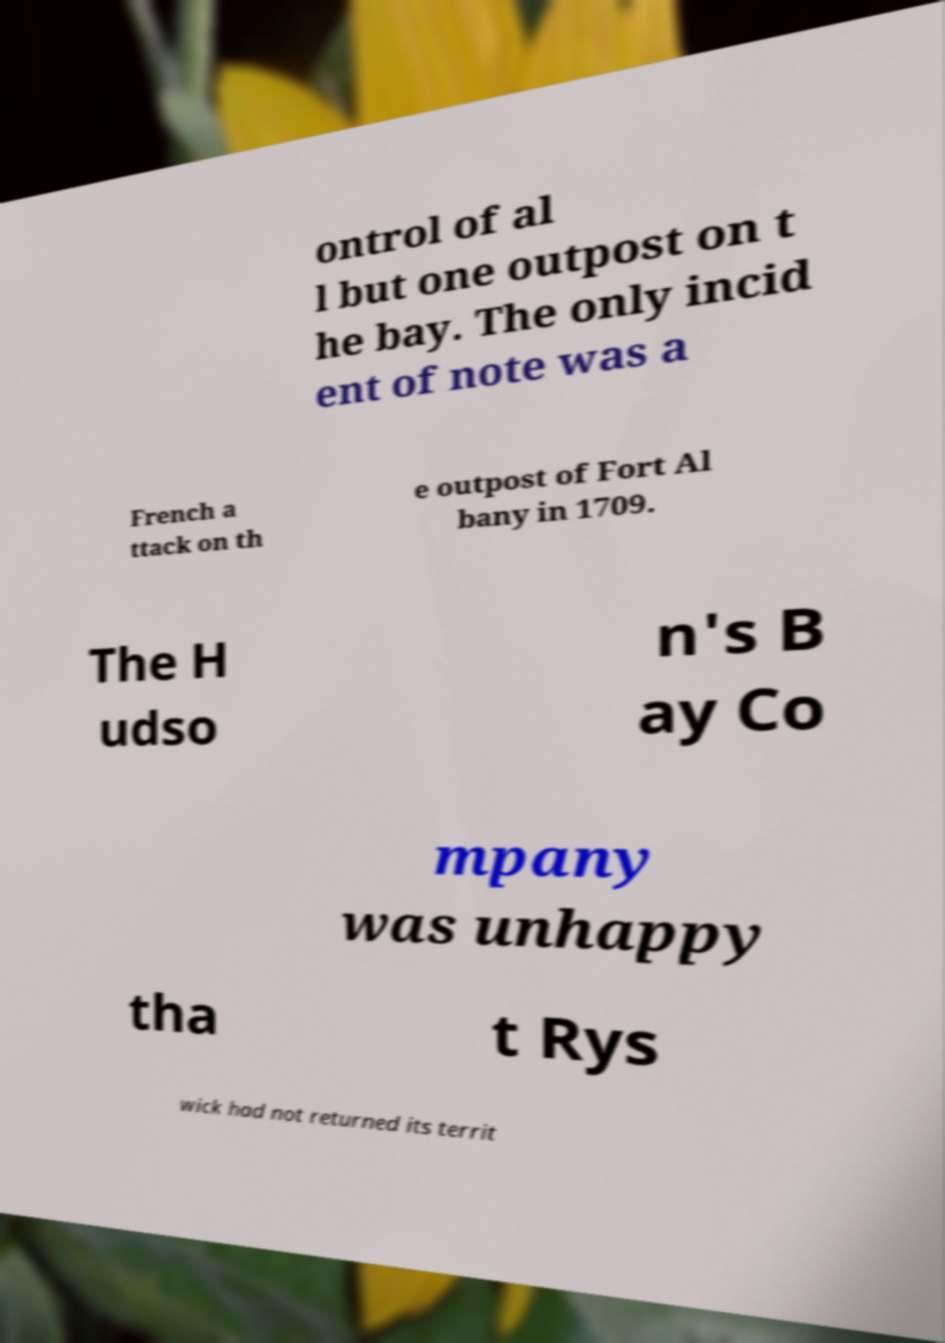Could you assist in decoding the text presented in this image and type it out clearly? ontrol of al l but one outpost on t he bay. The only incid ent of note was a French a ttack on th e outpost of Fort Al bany in 1709. The H udso n's B ay Co mpany was unhappy tha t Rys wick had not returned its territ 